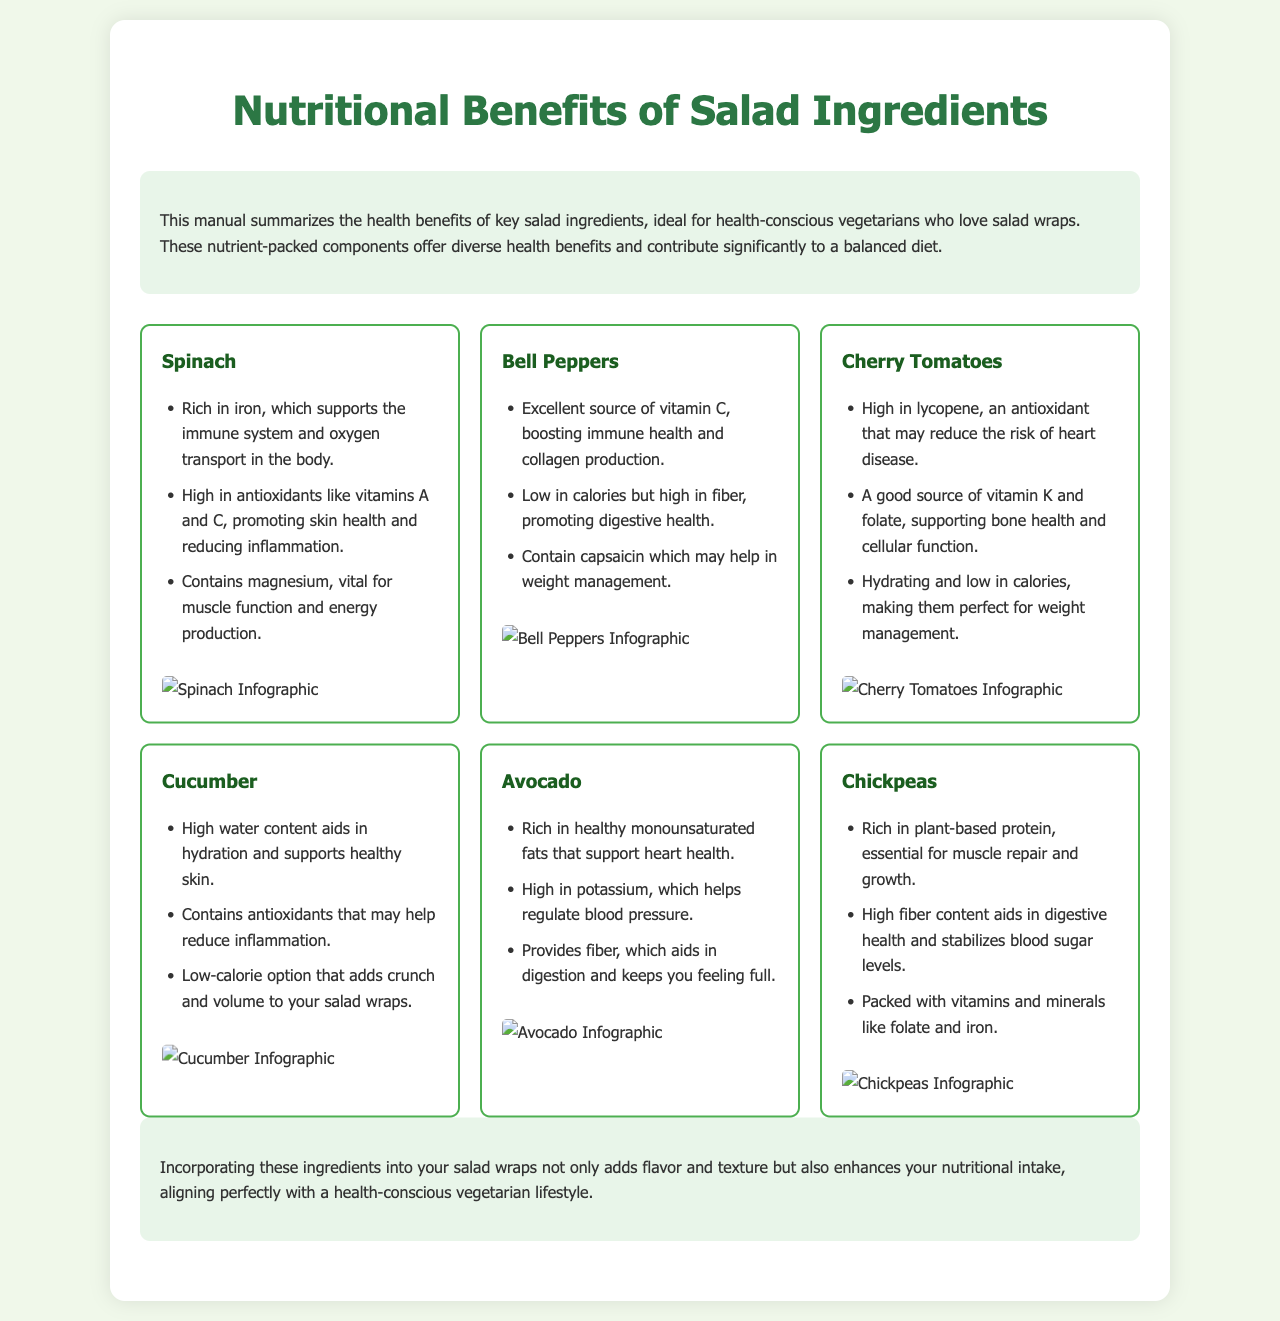What is the title of the manual? The title is stated at the top of the document, which clearly indicates the subject of the content.
Answer: Nutritional Benefits of Salad Ingredients Which ingredient is high in iron? The manual specifies spinach as rich in iron, highlighting its health benefits.
Answer: Spinach How many benefits are listed for Avocado? The document includes a bullet list detailing multiple health benefits of avocado, specifically counting them demonstrates understanding of the content.
Answer: Three What are the antioxidants found in Spinach? The manual mentions specific antioxidants associated with spinach, connecting them to health advantages.
Answer: Vitamins A and C Which ingredient is an excellent source of vitamin C? The document specifically states that bell peppers are an excellent source of this vitamin, emphasizing their nutritional value.
Answer: Bell Peppers Which salad ingredient aids in hydration? The manual describes the high water content of cucumber and its benefits related to hydration.
Answer: Cucumber What is the primary protein source listed? The mention of chickpeas as rich in plant-based protein indicates its significance in the salad ingredients.
Answer: Chickpeas How many ingredients have infographics? Each ingredient listed in the document has an accompanying infographic, which visually represents the nutritional data.
Answer: Six 